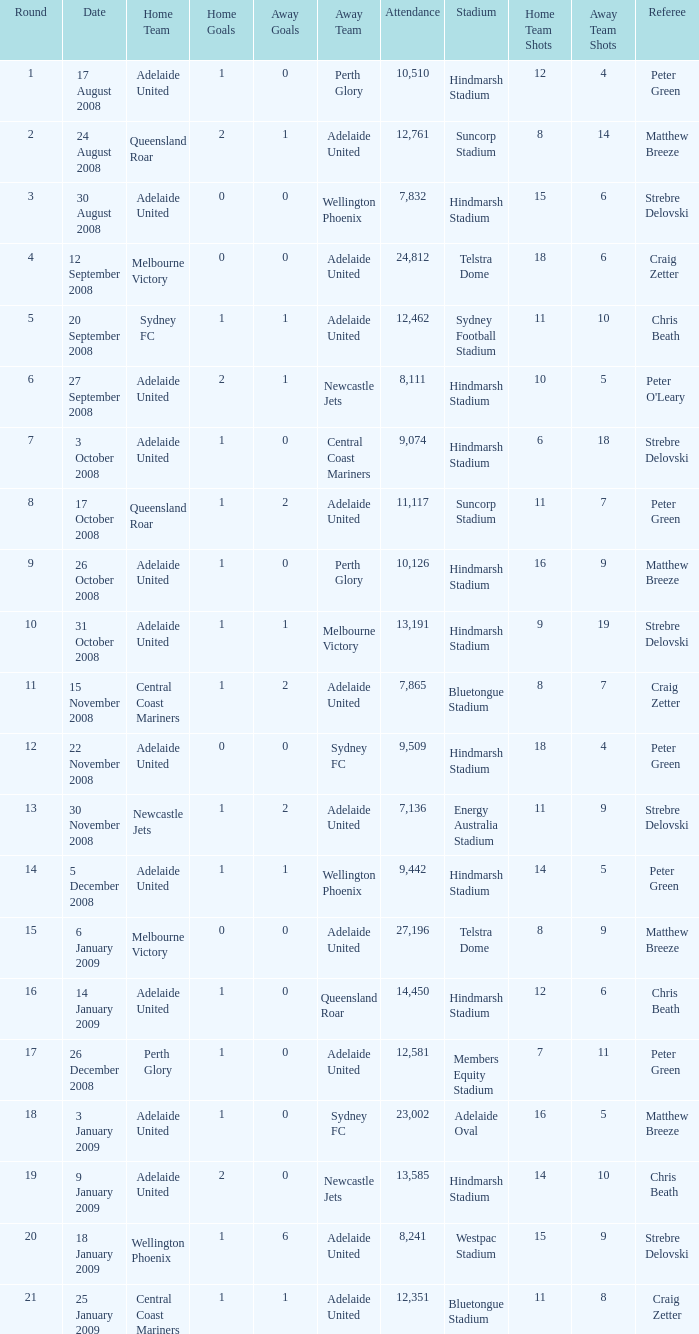What is the round when 11,117 people attended the game on 26 October 2008? 9.0. 